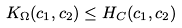<formula> <loc_0><loc_0><loc_500><loc_500>K _ { \Omega } ( c _ { 1 } , c _ { 2 } ) \leq H _ { C } ( c _ { 1 } , c _ { 2 } )</formula> 